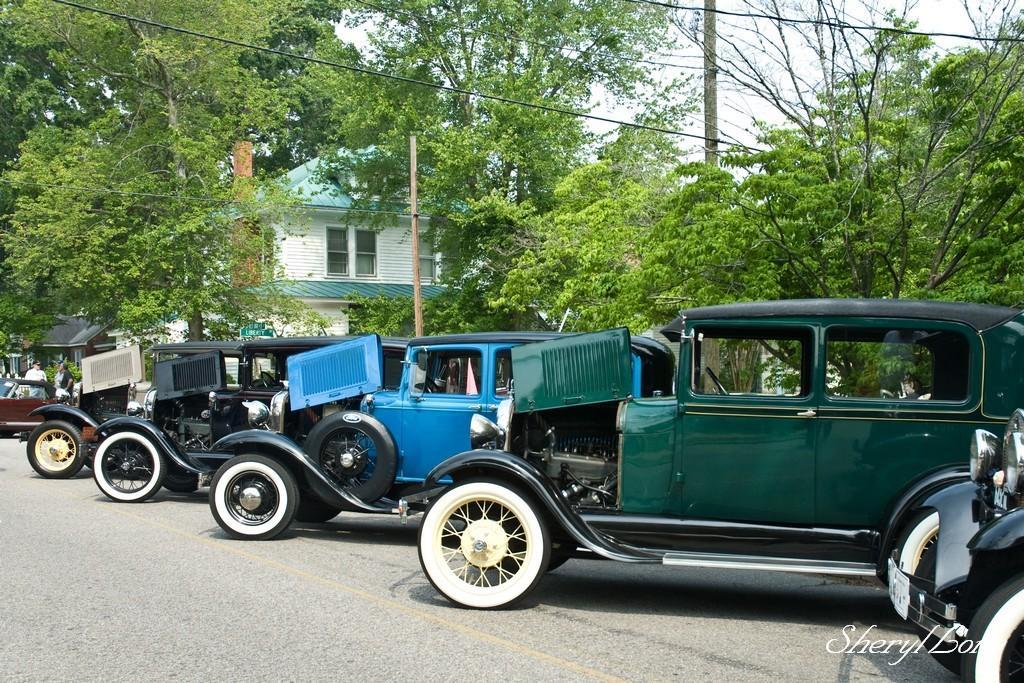In one or two sentences, can you explain what this image depicts? In this image I can see few vehicles. In front the vehicle is in green and blue color, background I can see a house in white and green color, trees in green color, an electric pole and the sky is in white color. 